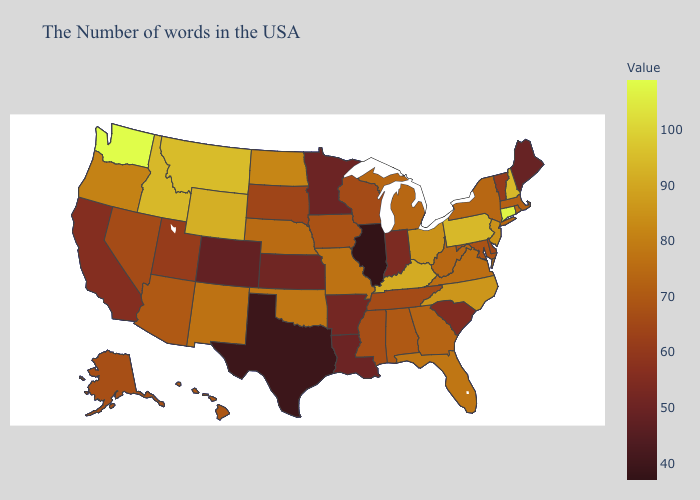Among the states that border Virginia , does North Carolina have the highest value?
Short answer required. No. Which states have the highest value in the USA?
Answer briefly. Washington. Which states hav the highest value in the South?
Concise answer only. Kentucky. Among the states that border Nevada , which have the highest value?
Quick response, please. Idaho. Among the states that border Connecticut , which have the lowest value?
Write a very short answer. Massachusetts. 